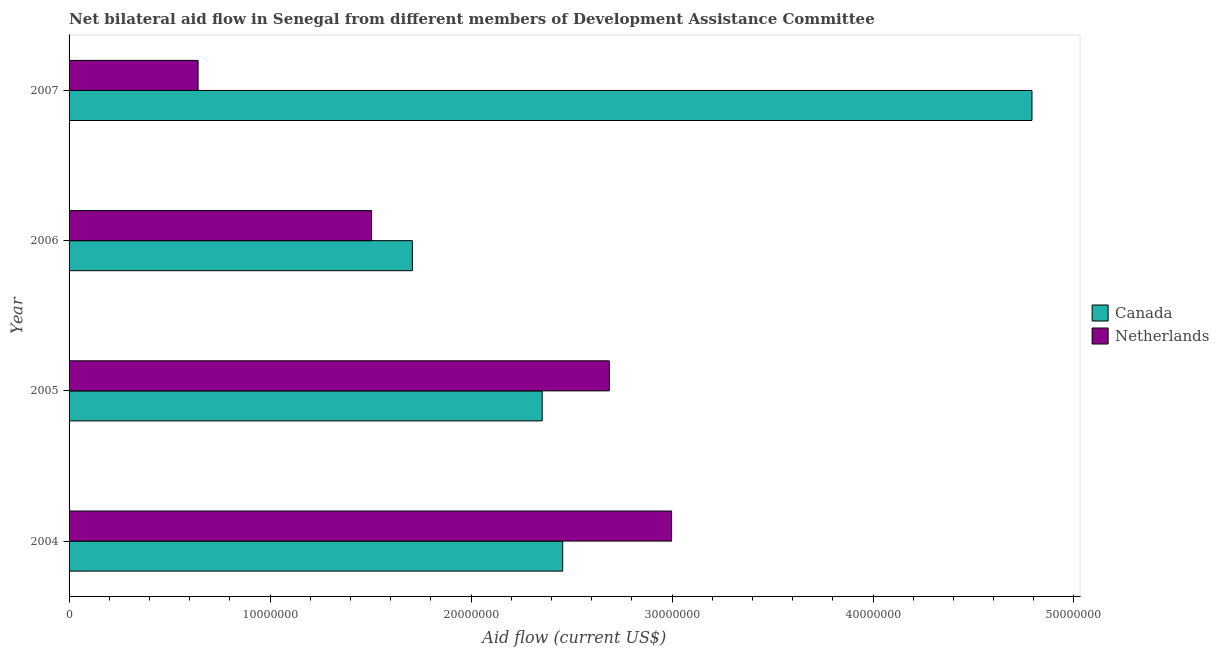How many different coloured bars are there?
Offer a terse response. 2. Are the number of bars per tick equal to the number of legend labels?
Make the answer very short. Yes. In how many cases, is the number of bars for a given year not equal to the number of legend labels?
Ensure brevity in your answer.  0. What is the amount of aid given by canada in 2004?
Provide a succinct answer. 2.46e+07. Across all years, what is the maximum amount of aid given by netherlands?
Your response must be concise. 3.00e+07. Across all years, what is the minimum amount of aid given by canada?
Your answer should be compact. 1.71e+07. In which year was the amount of aid given by netherlands minimum?
Offer a very short reply. 2007. What is the total amount of aid given by canada in the graph?
Your response must be concise. 1.13e+08. What is the difference between the amount of aid given by canada in 2005 and that in 2007?
Your response must be concise. -2.44e+07. What is the difference between the amount of aid given by canada in 2004 and the amount of aid given by netherlands in 2006?
Offer a very short reply. 9.51e+06. What is the average amount of aid given by canada per year?
Your answer should be compact. 2.83e+07. In the year 2006, what is the difference between the amount of aid given by canada and amount of aid given by netherlands?
Give a very brief answer. 2.03e+06. In how many years, is the amount of aid given by canada greater than 8000000 US$?
Your response must be concise. 4. What is the ratio of the amount of aid given by netherlands in 2005 to that in 2007?
Offer a very short reply. 4.19. Is the amount of aid given by canada in 2005 less than that in 2006?
Provide a short and direct response. No. Is the difference between the amount of aid given by canada in 2005 and 2007 greater than the difference between the amount of aid given by netherlands in 2005 and 2007?
Ensure brevity in your answer.  No. What is the difference between the highest and the second highest amount of aid given by canada?
Provide a short and direct response. 2.34e+07. What is the difference between the highest and the lowest amount of aid given by netherlands?
Your response must be concise. 2.36e+07. In how many years, is the amount of aid given by netherlands greater than the average amount of aid given by netherlands taken over all years?
Provide a short and direct response. 2. Is the sum of the amount of aid given by netherlands in 2006 and 2007 greater than the maximum amount of aid given by canada across all years?
Provide a short and direct response. No. What does the 2nd bar from the top in 2004 represents?
Provide a short and direct response. Canada. How many bars are there?
Your answer should be compact. 8. Are the values on the major ticks of X-axis written in scientific E-notation?
Offer a terse response. No. Does the graph contain any zero values?
Give a very brief answer. No. Does the graph contain grids?
Provide a short and direct response. No. Where does the legend appear in the graph?
Ensure brevity in your answer.  Center right. How are the legend labels stacked?
Your answer should be very brief. Vertical. What is the title of the graph?
Give a very brief answer. Net bilateral aid flow in Senegal from different members of Development Assistance Committee. Does "GDP" appear as one of the legend labels in the graph?
Your answer should be compact. No. What is the label or title of the X-axis?
Keep it short and to the point. Aid flow (current US$). What is the label or title of the Y-axis?
Offer a very short reply. Year. What is the Aid flow (current US$) in Canada in 2004?
Provide a short and direct response. 2.46e+07. What is the Aid flow (current US$) in Netherlands in 2004?
Ensure brevity in your answer.  3.00e+07. What is the Aid flow (current US$) in Canada in 2005?
Give a very brief answer. 2.35e+07. What is the Aid flow (current US$) in Netherlands in 2005?
Ensure brevity in your answer.  2.69e+07. What is the Aid flow (current US$) in Canada in 2006?
Provide a succinct answer. 1.71e+07. What is the Aid flow (current US$) of Netherlands in 2006?
Make the answer very short. 1.50e+07. What is the Aid flow (current US$) in Canada in 2007?
Provide a short and direct response. 4.79e+07. What is the Aid flow (current US$) of Netherlands in 2007?
Your answer should be very brief. 6.42e+06. Across all years, what is the maximum Aid flow (current US$) in Canada?
Ensure brevity in your answer.  4.79e+07. Across all years, what is the maximum Aid flow (current US$) in Netherlands?
Provide a short and direct response. 3.00e+07. Across all years, what is the minimum Aid flow (current US$) in Canada?
Give a very brief answer. 1.71e+07. Across all years, what is the minimum Aid flow (current US$) of Netherlands?
Keep it short and to the point. 6.42e+06. What is the total Aid flow (current US$) in Canada in the graph?
Provide a succinct answer. 1.13e+08. What is the total Aid flow (current US$) of Netherlands in the graph?
Your answer should be very brief. 7.83e+07. What is the difference between the Aid flow (current US$) in Canada in 2004 and that in 2005?
Offer a very short reply. 1.02e+06. What is the difference between the Aid flow (current US$) of Netherlands in 2004 and that in 2005?
Ensure brevity in your answer.  3.10e+06. What is the difference between the Aid flow (current US$) of Canada in 2004 and that in 2006?
Offer a very short reply. 7.48e+06. What is the difference between the Aid flow (current US$) in Netherlands in 2004 and that in 2006?
Offer a very short reply. 1.49e+07. What is the difference between the Aid flow (current US$) in Canada in 2004 and that in 2007?
Provide a short and direct response. -2.34e+07. What is the difference between the Aid flow (current US$) of Netherlands in 2004 and that in 2007?
Your answer should be very brief. 2.36e+07. What is the difference between the Aid flow (current US$) in Canada in 2005 and that in 2006?
Offer a very short reply. 6.46e+06. What is the difference between the Aid flow (current US$) in Netherlands in 2005 and that in 2006?
Provide a short and direct response. 1.18e+07. What is the difference between the Aid flow (current US$) in Canada in 2005 and that in 2007?
Offer a very short reply. -2.44e+07. What is the difference between the Aid flow (current US$) of Netherlands in 2005 and that in 2007?
Offer a very short reply. 2.05e+07. What is the difference between the Aid flow (current US$) in Canada in 2006 and that in 2007?
Make the answer very short. -3.08e+07. What is the difference between the Aid flow (current US$) of Netherlands in 2006 and that in 2007?
Give a very brief answer. 8.63e+06. What is the difference between the Aid flow (current US$) in Canada in 2004 and the Aid flow (current US$) in Netherlands in 2005?
Your response must be concise. -2.32e+06. What is the difference between the Aid flow (current US$) in Canada in 2004 and the Aid flow (current US$) in Netherlands in 2006?
Your response must be concise. 9.51e+06. What is the difference between the Aid flow (current US$) in Canada in 2004 and the Aid flow (current US$) in Netherlands in 2007?
Offer a terse response. 1.81e+07. What is the difference between the Aid flow (current US$) in Canada in 2005 and the Aid flow (current US$) in Netherlands in 2006?
Your response must be concise. 8.49e+06. What is the difference between the Aid flow (current US$) of Canada in 2005 and the Aid flow (current US$) of Netherlands in 2007?
Your response must be concise. 1.71e+07. What is the difference between the Aid flow (current US$) of Canada in 2006 and the Aid flow (current US$) of Netherlands in 2007?
Give a very brief answer. 1.07e+07. What is the average Aid flow (current US$) of Canada per year?
Keep it short and to the point. 2.83e+07. What is the average Aid flow (current US$) of Netherlands per year?
Give a very brief answer. 1.96e+07. In the year 2004, what is the difference between the Aid flow (current US$) of Canada and Aid flow (current US$) of Netherlands?
Provide a short and direct response. -5.42e+06. In the year 2005, what is the difference between the Aid flow (current US$) in Canada and Aid flow (current US$) in Netherlands?
Offer a terse response. -3.34e+06. In the year 2006, what is the difference between the Aid flow (current US$) of Canada and Aid flow (current US$) of Netherlands?
Your response must be concise. 2.03e+06. In the year 2007, what is the difference between the Aid flow (current US$) of Canada and Aid flow (current US$) of Netherlands?
Provide a short and direct response. 4.15e+07. What is the ratio of the Aid flow (current US$) of Canada in 2004 to that in 2005?
Your response must be concise. 1.04. What is the ratio of the Aid flow (current US$) of Netherlands in 2004 to that in 2005?
Make the answer very short. 1.12. What is the ratio of the Aid flow (current US$) of Canada in 2004 to that in 2006?
Your answer should be compact. 1.44. What is the ratio of the Aid flow (current US$) of Netherlands in 2004 to that in 2006?
Your answer should be very brief. 1.99. What is the ratio of the Aid flow (current US$) in Canada in 2004 to that in 2007?
Your answer should be very brief. 0.51. What is the ratio of the Aid flow (current US$) in Netherlands in 2004 to that in 2007?
Provide a short and direct response. 4.67. What is the ratio of the Aid flow (current US$) of Canada in 2005 to that in 2006?
Your answer should be very brief. 1.38. What is the ratio of the Aid flow (current US$) of Netherlands in 2005 to that in 2006?
Give a very brief answer. 1.79. What is the ratio of the Aid flow (current US$) in Canada in 2005 to that in 2007?
Provide a short and direct response. 0.49. What is the ratio of the Aid flow (current US$) in Netherlands in 2005 to that in 2007?
Your response must be concise. 4.19. What is the ratio of the Aid flow (current US$) in Canada in 2006 to that in 2007?
Give a very brief answer. 0.36. What is the ratio of the Aid flow (current US$) of Netherlands in 2006 to that in 2007?
Ensure brevity in your answer.  2.34. What is the difference between the highest and the second highest Aid flow (current US$) of Canada?
Ensure brevity in your answer.  2.34e+07. What is the difference between the highest and the second highest Aid flow (current US$) in Netherlands?
Your answer should be compact. 3.10e+06. What is the difference between the highest and the lowest Aid flow (current US$) of Canada?
Offer a very short reply. 3.08e+07. What is the difference between the highest and the lowest Aid flow (current US$) in Netherlands?
Your answer should be compact. 2.36e+07. 